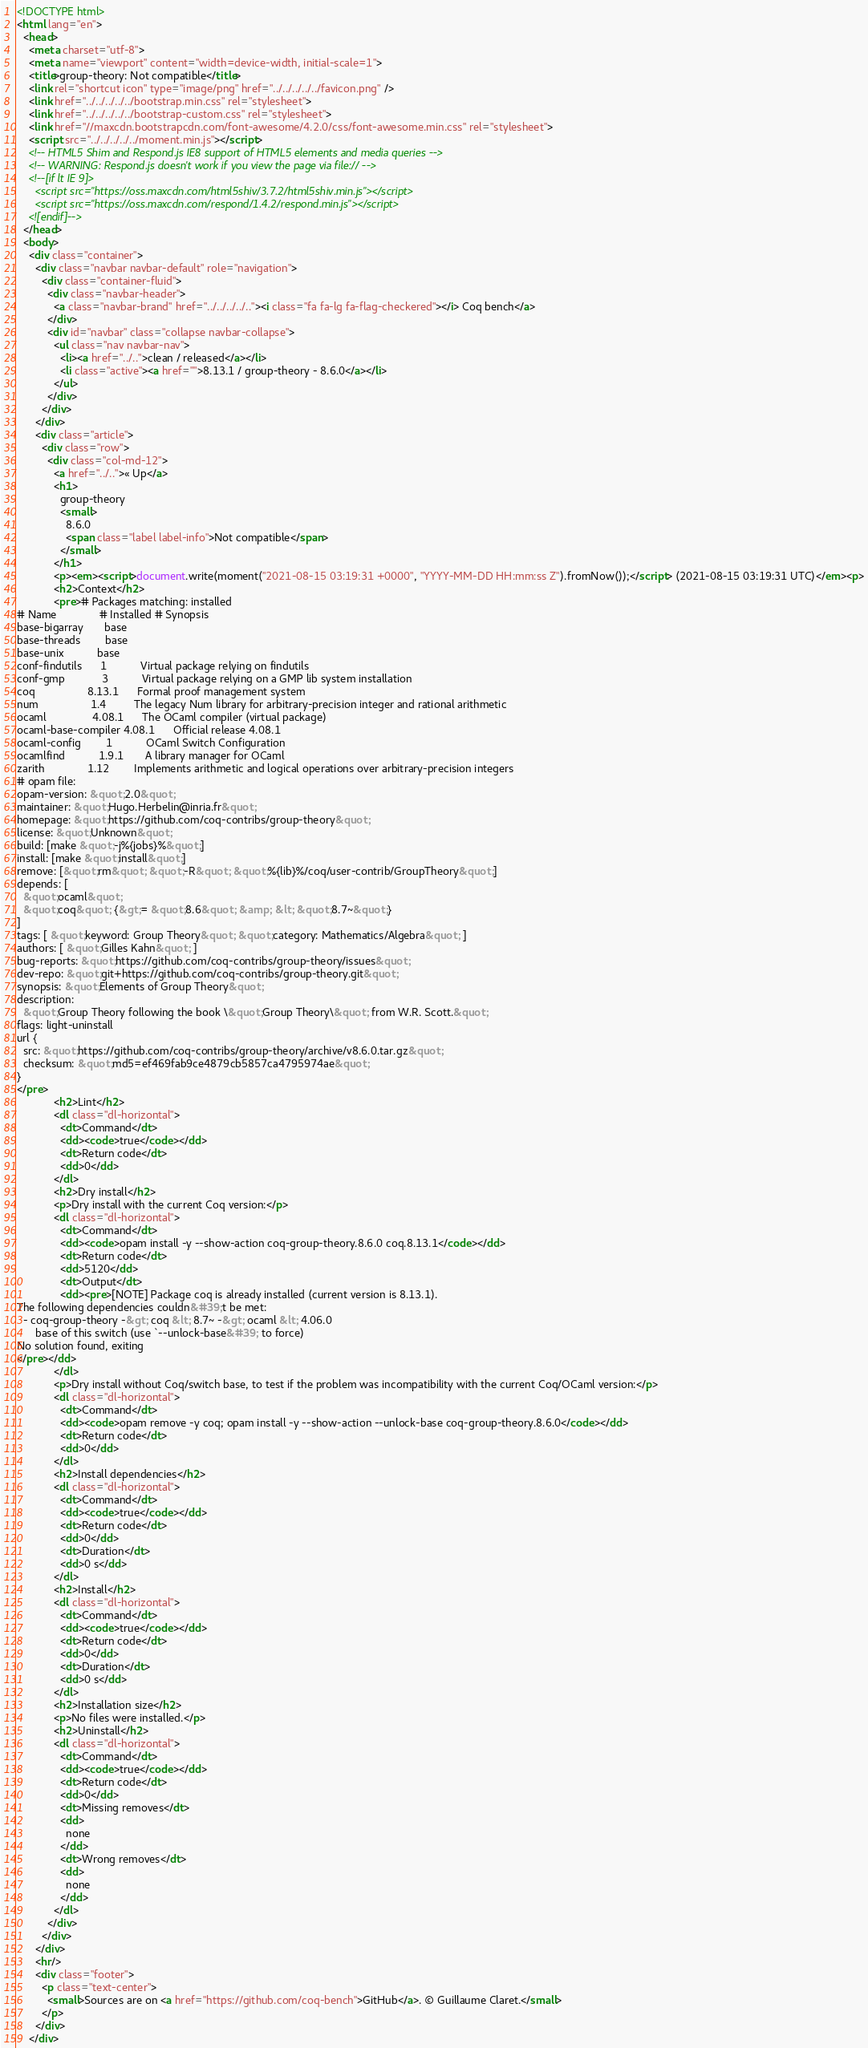Convert code to text. <code><loc_0><loc_0><loc_500><loc_500><_HTML_><!DOCTYPE html>
<html lang="en">
  <head>
    <meta charset="utf-8">
    <meta name="viewport" content="width=device-width, initial-scale=1">
    <title>group-theory: Not compatible</title>
    <link rel="shortcut icon" type="image/png" href="../../../../../favicon.png" />
    <link href="../../../../../bootstrap.min.css" rel="stylesheet">
    <link href="../../../../../bootstrap-custom.css" rel="stylesheet">
    <link href="//maxcdn.bootstrapcdn.com/font-awesome/4.2.0/css/font-awesome.min.css" rel="stylesheet">
    <script src="../../../../../moment.min.js"></script>
    <!-- HTML5 Shim and Respond.js IE8 support of HTML5 elements and media queries -->
    <!-- WARNING: Respond.js doesn't work if you view the page via file:// -->
    <!--[if lt IE 9]>
      <script src="https://oss.maxcdn.com/html5shiv/3.7.2/html5shiv.min.js"></script>
      <script src="https://oss.maxcdn.com/respond/1.4.2/respond.min.js"></script>
    <![endif]-->
  </head>
  <body>
    <div class="container">
      <div class="navbar navbar-default" role="navigation">
        <div class="container-fluid">
          <div class="navbar-header">
            <a class="navbar-brand" href="../../../../.."><i class="fa fa-lg fa-flag-checkered"></i> Coq bench</a>
          </div>
          <div id="navbar" class="collapse navbar-collapse">
            <ul class="nav navbar-nav">
              <li><a href="../..">clean / released</a></li>
              <li class="active"><a href="">8.13.1 / group-theory - 8.6.0</a></li>
            </ul>
          </div>
        </div>
      </div>
      <div class="article">
        <div class="row">
          <div class="col-md-12">
            <a href="../..">« Up</a>
            <h1>
              group-theory
              <small>
                8.6.0
                <span class="label label-info">Not compatible</span>
              </small>
            </h1>
            <p><em><script>document.write(moment("2021-08-15 03:19:31 +0000", "YYYY-MM-DD HH:mm:ss Z").fromNow());</script> (2021-08-15 03:19:31 UTC)</em><p>
            <h2>Context</h2>
            <pre># Packages matching: installed
# Name              # Installed # Synopsis
base-bigarray       base
base-threads        base
base-unix           base
conf-findutils      1           Virtual package relying on findutils
conf-gmp            3           Virtual package relying on a GMP lib system installation
coq                 8.13.1      Formal proof management system
num                 1.4         The legacy Num library for arbitrary-precision integer and rational arithmetic
ocaml               4.08.1      The OCaml compiler (virtual package)
ocaml-base-compiler 4.08.1      Official release 4.08.1
ocaml-config        1           OCaml Switch Configuration
ocamlfind           1.9.1       A library manager for OCaml
zarith              1.12        Implements arithmetic and logical operations over arbitrary-precision integers
# opam file:
opam-version: &quot;2.0&quot;
maintainer: &quot;Hugo.Herbelin@inria.fr&quot;
homepage: &quot;https://github.com/coq-contribs/group-theory&quot;
license: &quot;Unknown&quot;
build: [make &quot;-j%{jobs}%&quot;]
install: [make &quot;install&quot;]
remove: [&quot;rm&quot; &quot;-R&quot; &quot;%{lib}%/coq/user-contrib/GroupTheory&quot;]
depends: [
  &quot;ocaml&quot;
  &quot;coq&quot; {&gt;= &quot;8.6&quot; &amp; &lt; &quot;8.7~&quot;}
]
tags: [ &quot;keyword: Group Theory&quot; &quot;category: Mathematics/Algebra&quot; ]
authors: [ &quot;Gilles Kahn&quot; ]
bug-reports: &quot;https://github.com/coq-contribs/group-theory/issues&quot;
dev-repo: &quot;git+https://github.com/coq-contribs/group-theory.git&quot;
synopsis: &quot;Elements of Group Theory&quot;
description:
  &quot;Group Theory following the book \&quot;Group Theory\&quot; from W.R. Scott.&quot;
flags: light-uninstall
url {
  src: &quot;https://github.com/coq-contribs/group-theory/archive/v8.6.0.tar.gz&quot;
  checksum: &quot;md5=ef469fab9ce4879cb5857ca4795974ae&quot;
}
</pre>
            <h2>Lint</h2>
            <dl class="dl-horizontal">
              <dt>Command</dt>
              <dd><code>true</code></dd>
              <dt>Return code</dt>
              <dd>0</dd>
            </dl>
            <h2>Dry install</h2>
            <p>Dry install with the current Coq version:</p>
            <dl class="dl-horizontal">
              <dt>Command</dt>
              <dd><code>opam install -y --show-action coq-group-theory.8.6.0 coq.8.13.1</code></dd>
              <dt>Return code</dt>
              <dd>5120</dd>
              <dt>Output</dt>
              <dd><pre>[NOTE] Package coq is already installed (current version is 8.13.1).
The following dependencies couldn&#39;t be met:
  - coq-group-theory -&gt; coq &lt; 8.7~ -&gt; ocaml &lt; 4.06.0
      base of this switch (use `--unlock-base&#39; to force)
No solution found, exiting
</pre></dd>
            </dl>
            <p>Dry install without Coq/switch base, to test if the problem was incompatibility with the current Coq/OCaml version:</p>
            <dl class="dl-horizontal">
              <dt>Command</dt>
              <dd><code>opam remove -y coq; opam install -y --show-action --unlock-base coq-group-theory.8.6.0</code></dd>
              <dt>Return code</dt>
              <dd>0</dd>
            </dl>
            <h2>Install dependencies</h2>
            <dl class="dl-horizontal">
              <dt>Command</dt>
              <dd><code>true</code></dd>
              <dt>Return code</dt>
              <dd>0</dd>
              <dt>Duration</dt>
              <dd>0 s</dd>
            </dl>
            <h2>Install</h2>
            <dl class="dl-horizontal">
              <dt>Command</dt>
              <dd><code>true</code></dd>
              <dt>Return code</dt>
              <dd>0</dd>
              <dt>Duration</dt>
              <dd>0 s</dd>
            </dl>
            <h2>Installation size</h2>
            <p>No files were installed.</p>
            <h2>Uninstall</h2>
            <dl class="dl-horizontal">
              <dt>Command</dt>
              <dd><code>true</code></dd>
              <dt>Return code</dt>
              <dd>0</dd>
              <dt>Missing removes</dt>
              <dd>
                none
              </dd>
              <dt>Wrong removes</dt>
              <dd>
                none
              </dd>
            </dl>
          </div>
        </div>
      </div>
      <hr/>
      <div class="footer">
        <p class="text-center">
          <small>Sources are on <a href="https://github.com/coq-bench">GitHub</a>. © Guillaume Claret.</small>
        </p>
      </div>
    </div></code> 